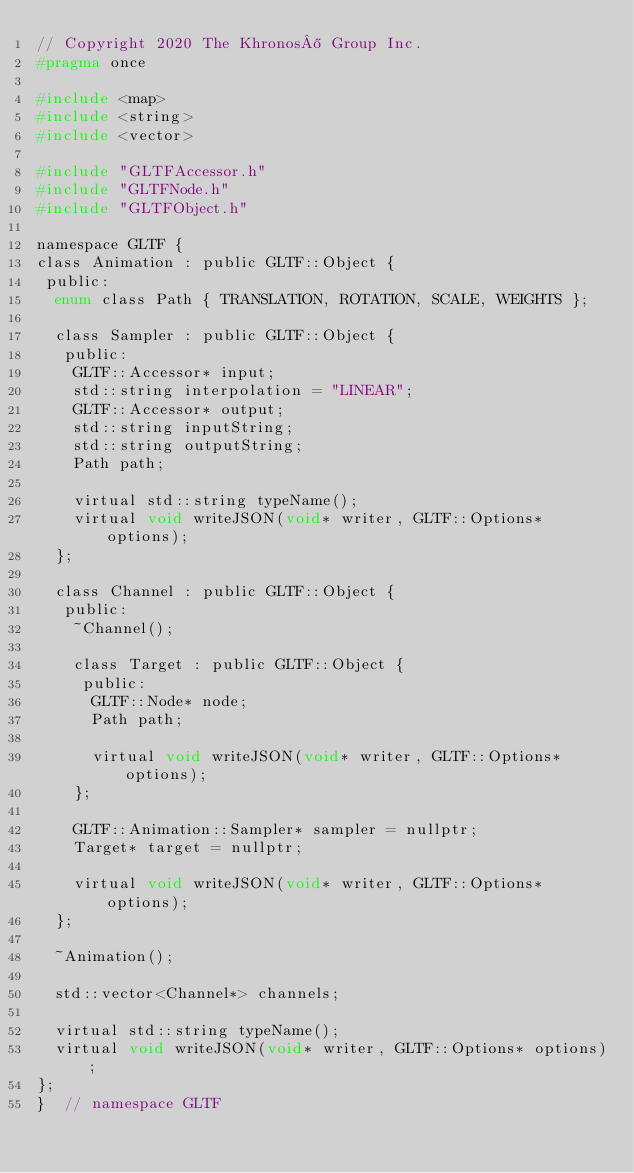<code> <loc_0><loc_0><loc_500><loc_500><_C_>// Copyright 2020 The Khronos® Group Inc.
#pragma once

#include <map>
#include <string>
#include <vector>

#include "GLTFAccessor.h"
#include "GLTFNode.h"
#include "GLTFObject.h"

namespace GLTF {
class Animation : public GLTF::Object {
 public:
  enum class Path { TRANSLATION, ROTATION, SCALE, WEIGHTS };

  class Sampler : public GLTF::Object {
   public:
    GLTF::Accessor* input;
    std::string interpolation = "LINEAR";
    GLTF::Accessor* output;
    std::string inputString;
    std::string outputString;
    Path path;

    virtual std::string typeName();
    virtual void writeJSON(void* writer, GLTF::Options* options);
  };

  class Channel : public GLTF::Object {
   public:
    ~Channel();

    class Target : public GLTF::Object {
     public:
      GLTF::Node* node;
      Path path;

      virtual void writeJSON(void* writer, GLTF::Options* options);
    };

    GLTF::Animation::Sampler* sampler = nullptr;
    Target* target = nullptr;

    virtual void writeJSON(void* writer, GLTF::Options* options);
  };

  ~Animation();

  std::vector<Channel*> channels;

  virtual std::string typeName();
  virtual void writeJSON(void* writer, GLTF::Options* options);
};
}  // namespace GLTF
</code> 